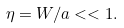Convert formula to latex. <formula><loc_0><loc_0><loc_500><loc_500>\eta = W / a < < 1 .</formula> 